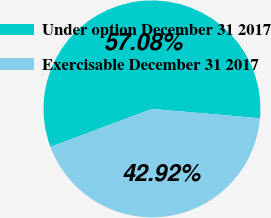Convert chart. <chart><loc_0><loc_0><loc_500><loc_500><pie_chart><fcel>Under option December 31 2017<fcel>Exercisable December 31 2017<nl><fcel>57.08%<fcel>42.92%<nl></chart> 